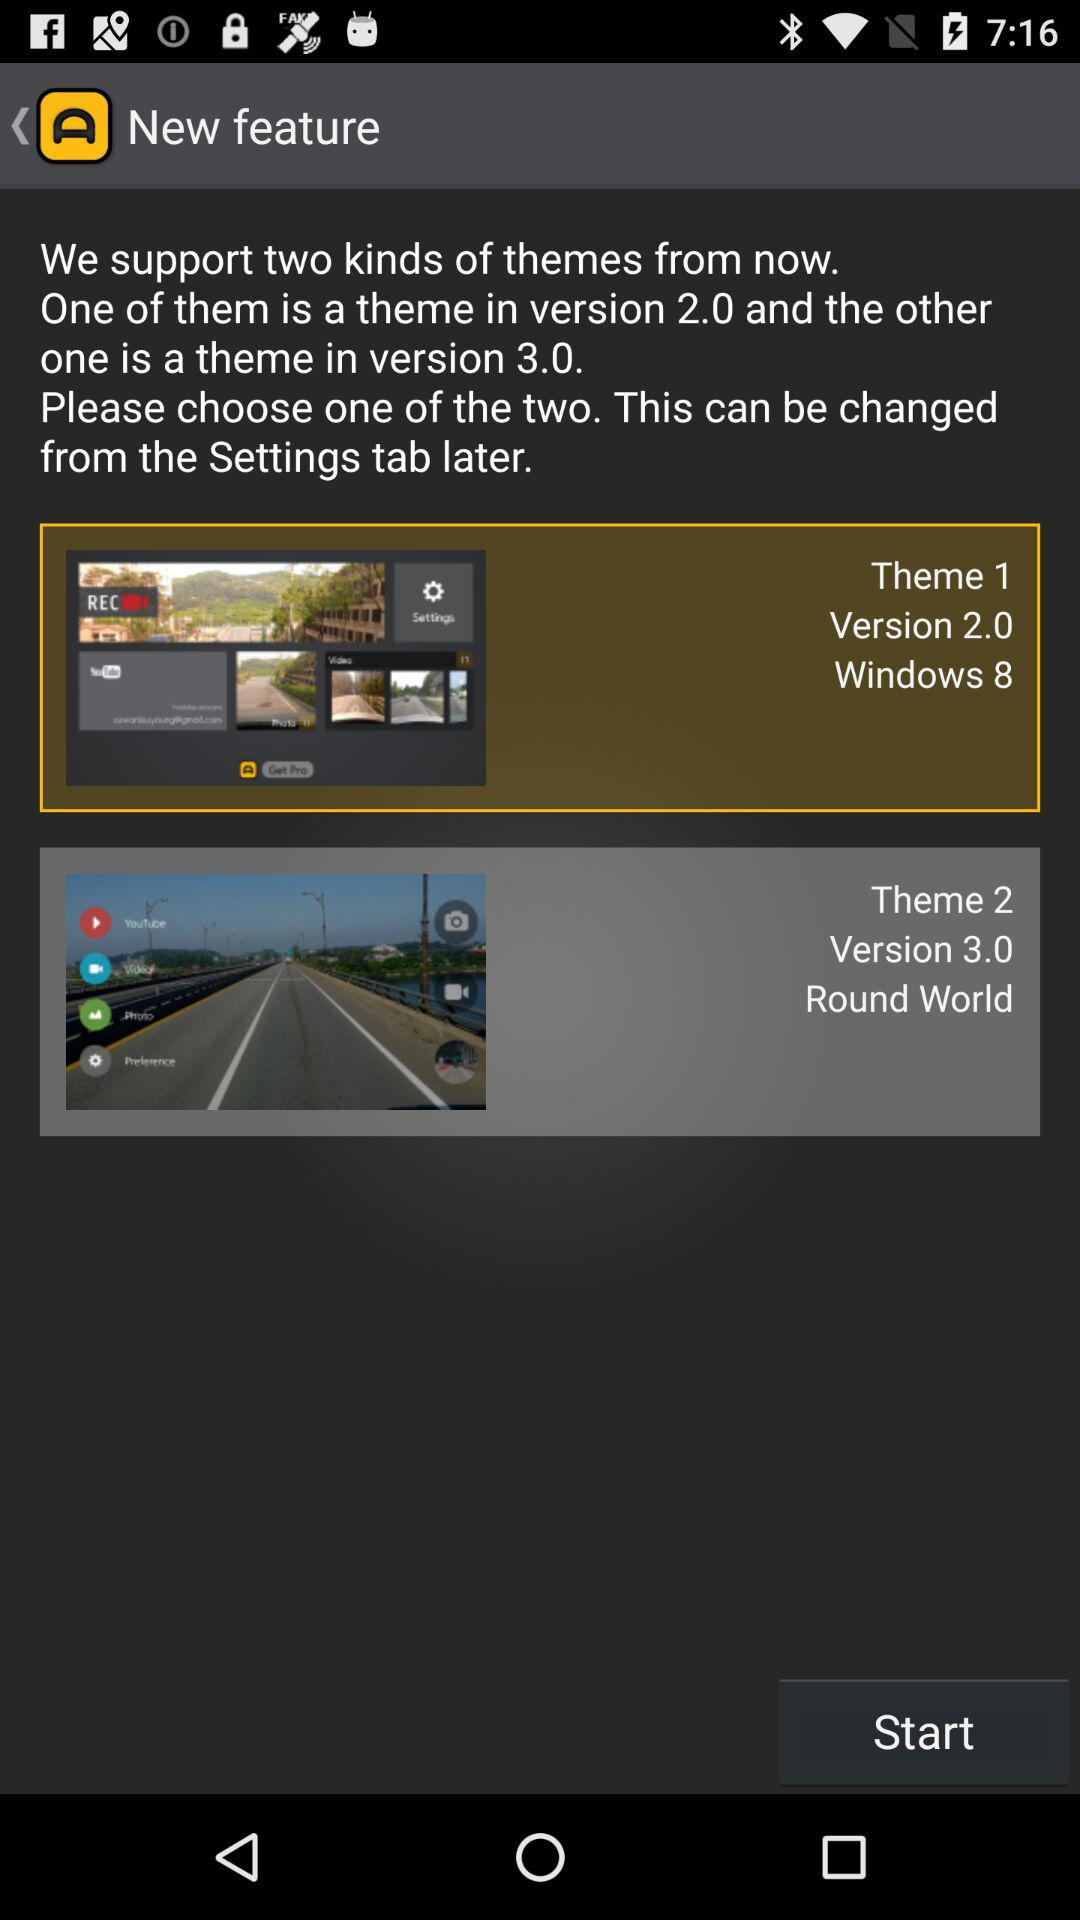Which theme is selected? The selected theme is "1". 